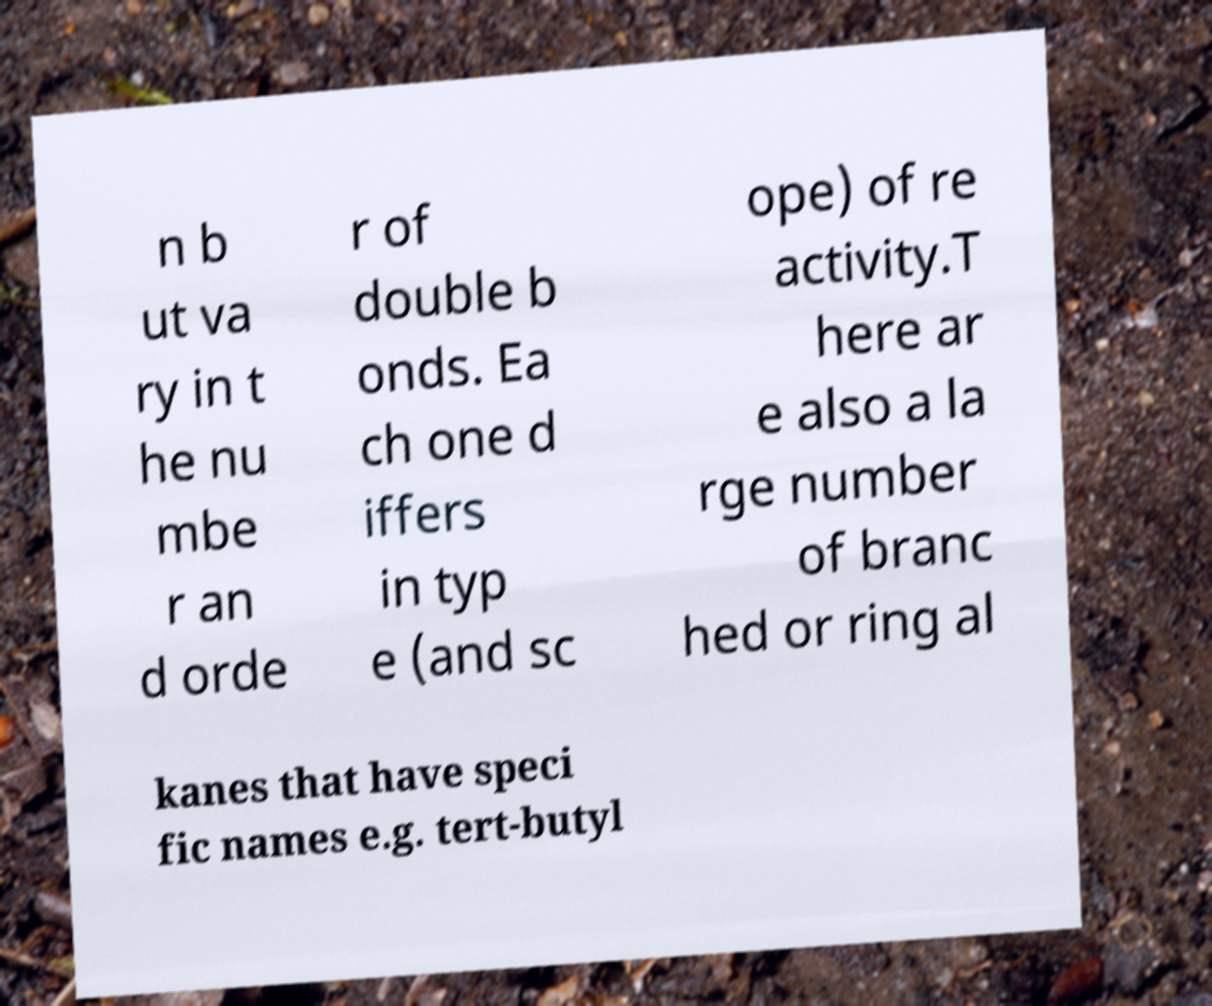What messages or text are displayed in this image? I need them in a readable, typed format. n b ut va ry in t he nu mbe r an d orde r of double b onds. Ea ch one d iffers in typ e (and sc ope) of re activity.T here ar e also a la rge number of branc hed or ring al kanes that have speci fic names e.g. tert-butyl 